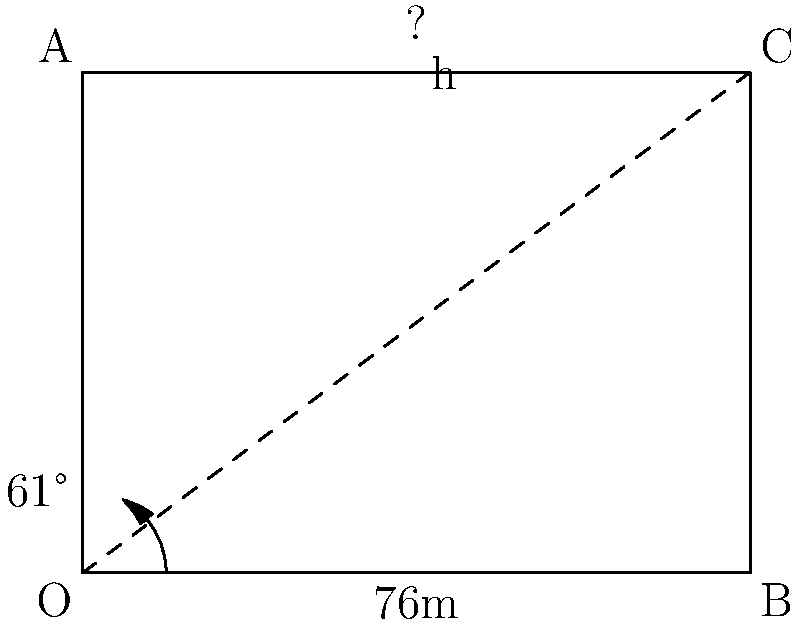As you admire York Minster from a distance, you recall your old trigonometry lessons. If you're standing 76 meters away from the base of the Minster and you measure the angle of elevation to the top of the central tower to be 61°, can you calculate the height of York Minster's central tower using vector projection? Round your answer to the nearest meter. Let's approach this step-by-step using vector projection:

1) First, let's define our vectors. Let $\vec{v}$ be the vector from the observer to the top of the tower, and $\vec{u}$ be the horizontal vector to the base of the tower.

2) We know that $|\vec{u}| = 76$ meters (the distance to the base).

3) The angle between $\vec{v}$ and $\vec{u}$ is 61°.

4) We can find the magnitude of $\vec{v}$ using the cosine formula:

   $\cos 61° = \frac{|\vec{u}|}{|\vec{v}|}$

5) Rearranging this:

   $|\vec{v}| = \frac{|\vec{u}|}{\cos 61°} = \frac{76}{\cos 61°}$

6) Now, we can find the height using the sine component of $\vec{v}$:

   $h = |\vec{v}| \sin 61°$

7) Substituting in our value for $|\vec{v}|$:

   $h = \frac{76}{\cos 61°} \sin 61°$

8) This simplifies to:

   $h = 76 \tan 61°$

9) Calculating this:

   $h \approx 76 \times 1.8040 \approx 137.104$ meters

10) Rounding to the nearest meter:

    $h \approx 137$ meters

Thus, using vector projection, we estimate the height of York Minster's central tower to be approximately 137 meters.
Answer: 137 meters 